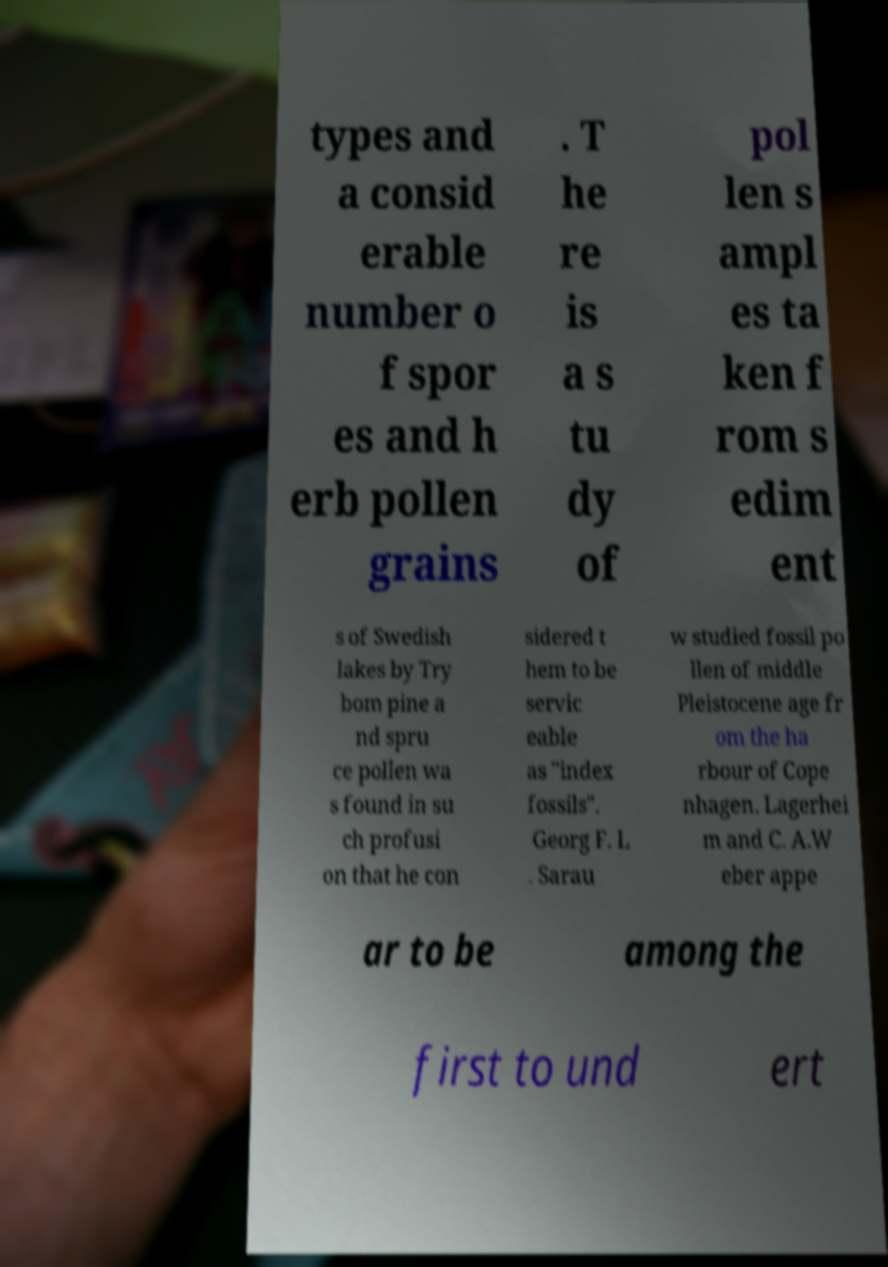Can you accurately transcribe the text from the provided image for me? types and a consid erable number o f spor es and h erb pollen grains . T he re is a s tu dy of pol len s ampl es ta ken f rom s edim ent s of Swedish lakes by Try bom pine a nd spru ce pollen wa s found in su ch profusi on that he con sidered t hem to be servic eable as "index fossils". Georg F. L . Sarau w studied fossil po llen of middle Pleistocene age fr om the ha rbour of Cope nhagen. Lagerhei m and C. A.W eber appe ar to be among the first to und ert 